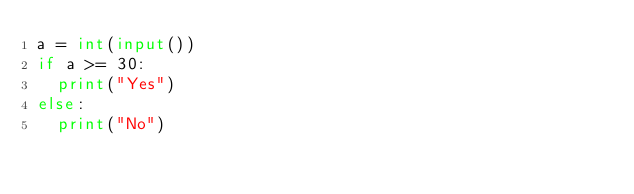Convert code to text. <code><loc_0><loc_0><loc_500><loc_500><_Python_>a = int(input())
if a >= 30:
  print("Yes")
else:
  print("No")</code> 